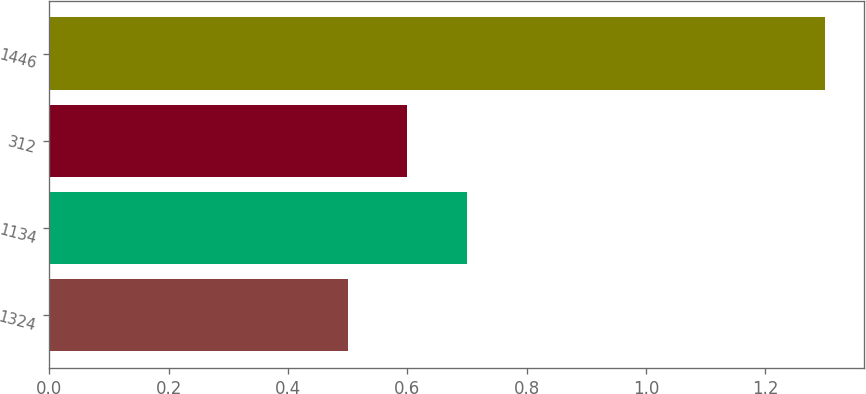Convert chart. <chart><loc_0><loc_0><loc_500><loc_500><bar_chart><fcel>1324<fcel>1134<fcel>312<fcel>1446<nl><fcel>0.5<fcel>0.7<fcel>0.6<fcel>1.3<nl></chart> 